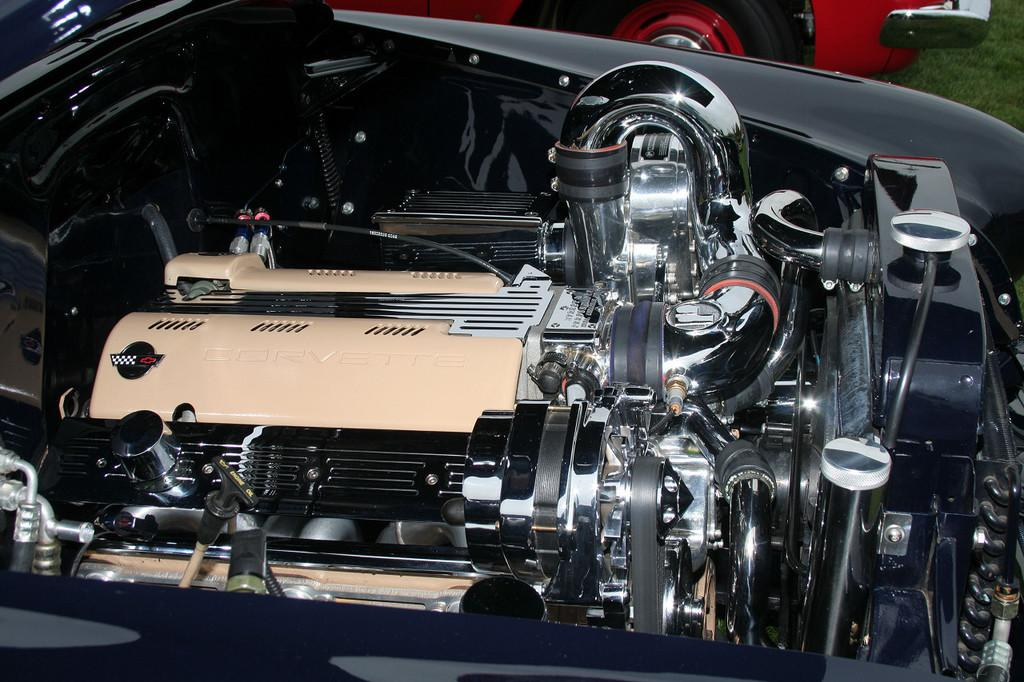What type of objects can be seen in the image? There are vehicle parts in the image. What type of natural environment is visible in the image? There is grass visible in the image. What can be inferred about the vehicle in the image? The vehicle appears to be truncated in the image. What type of legal advice is the judge providing in the image? There is no judge present in the image, so it is not possible to answer that question. 